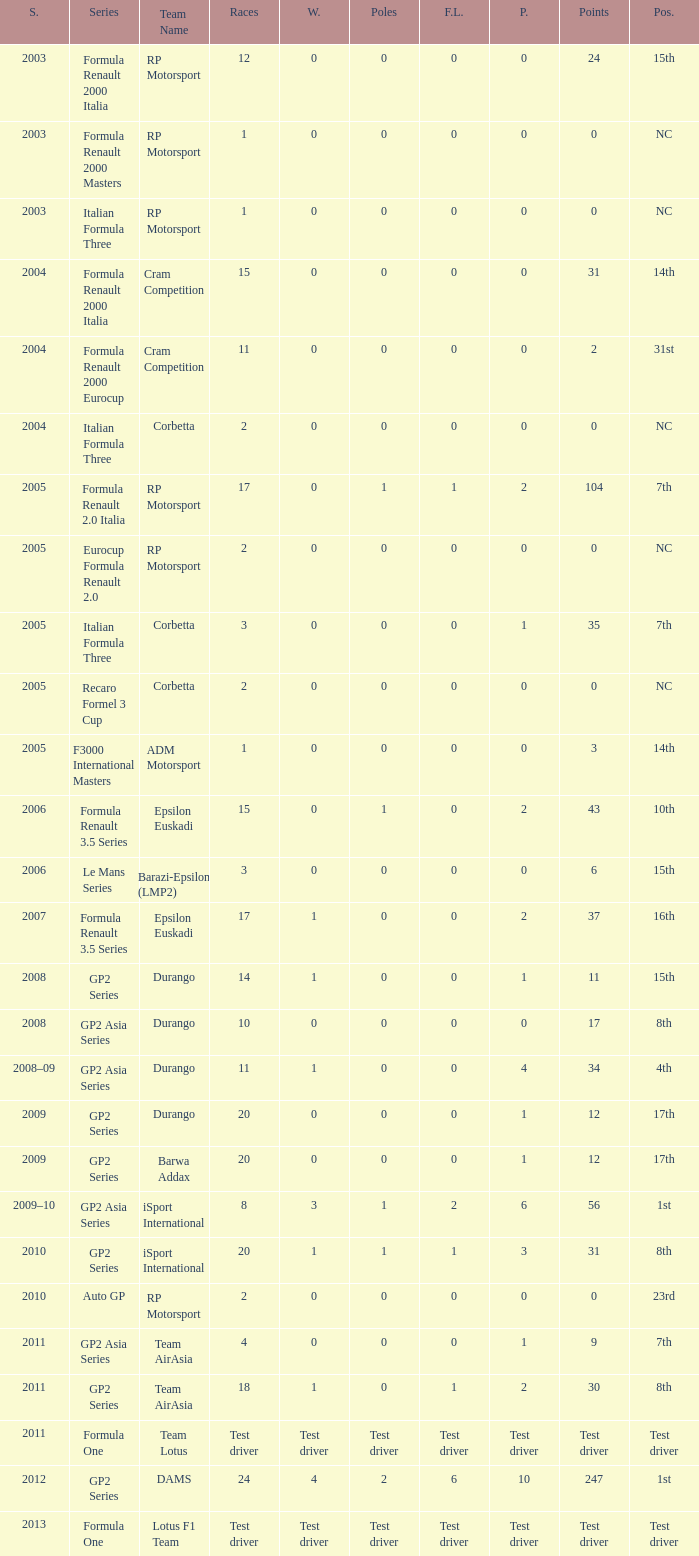What is the number of wins with a 0 F.L., 0 poles, a position of 7th, and 35 points? 0.0. 